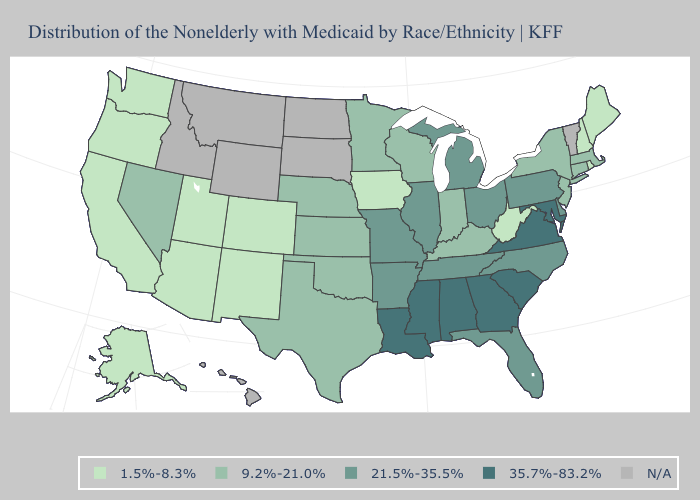Name the states that have a value in the range 9.2%-21.0%?
Keep it brief. Connecticut, Indiana, Kansas, Kentucky, Massachusetts, Minnesota, Nebraska, Nevada, New Jersey, New York, Oklahoma, Texas, Wisconsin. Does Virginia have the highest value in the USA?
Quick response, please. Yes. Which states have the lowest value in the MidWest?
Keep it brief. Iowa. Name the states that have a value in the range 1.5%-8.3%?
Write a very short answer. Alaska, Arizona, California, Colorado, Iowa, Maine, New Hampshire, New Mexico, Oregon, Rhode Island, Utah, Washington, West Virginia. What is the value of Hawaii?
Write a very short answer. N/A. Name the states that have a value in the range N/A?
Give a very brief answer. Hawaii, Idaho, Montana, North Dakota, South Dakota, Vermont, Wyoming. Among the states that border Arkansas , which have the lowest value?
Give a very brief answer. Oklahoma, Texas. What is the value of Alaska?
Short answer required. 1.5%-8.3%. Among the states that border Nevada , which have the highest value?
Short answer required. Arizona, California, Oregon, Utah. What is the value of Michigan?
Write a very short answer. 21.5%-35.5%. Among the states that border Missouri , which have the lowest value?
Concise answer only. Iowa. Does the map have missing data?
Be succinct. Yes. Does Arizona have the lowest value in the USA?
Short answer required. Yes. What is the value of Vermont?
Keep it brief. N/A. 